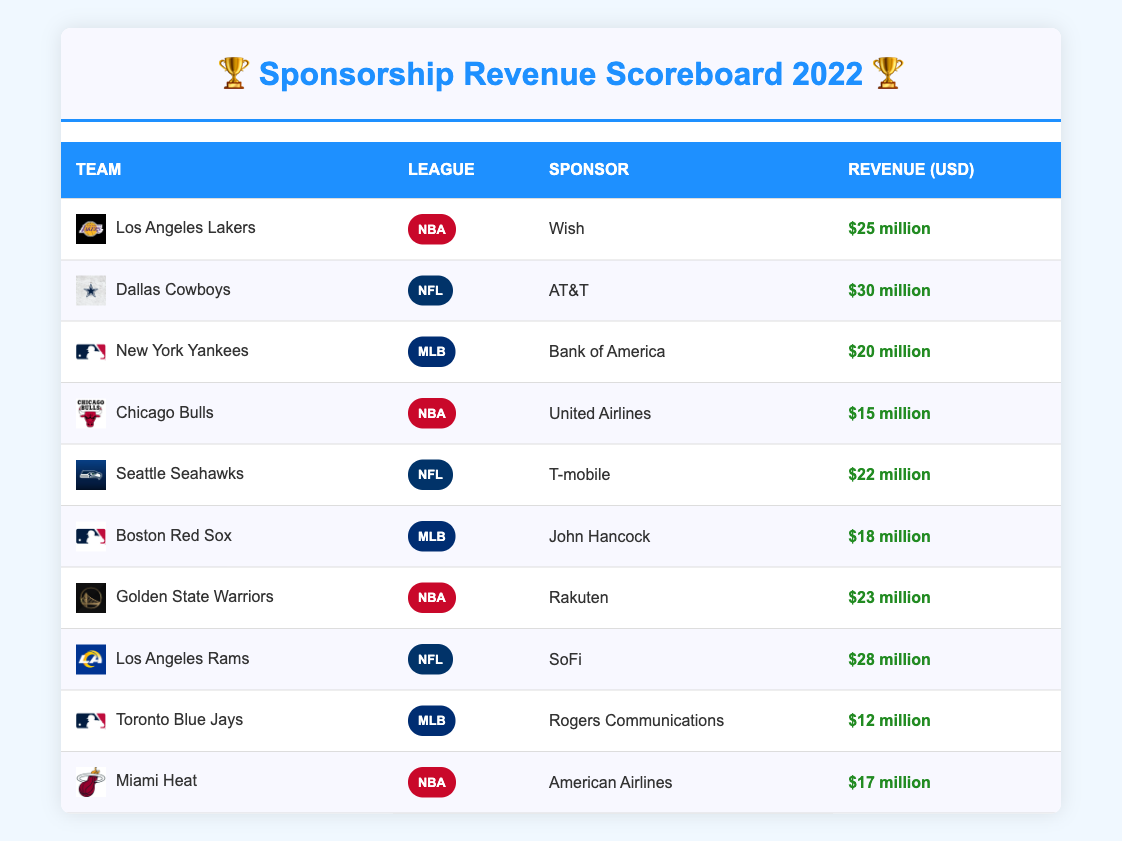What is the sponsorship revenue for the Dallas Cowboys? Looking at the table, the Dallas Cowboys are listed with a sponsorship revenue of $30 million.
Answer: $30 million Which NBA team has the highest sponsorship revenue? From the table, the Los Angeles Lakers have the highest sponsorship revenue among NBA teams at $25 million.
Answer: Los Angeles Lakers What is the total sponsorship revenue from all the teams? To find the total, we add up the revenues: 25 + 30 + 20 + 15 + 22 + 18 + 23 + 28 + 12 + 17 = 200. So, the total sponsorship revenue is $200 million.
Answer: $200 million Is the sponsorship revenue for the Miami Heat greater than that of the Chicago Bulls? The Miami Heat has a revenue of $17 million, while the Chicago Bulls have $15 million. Since 17 is greater than 15, the statement is true.
Answer: Yes What is the combined revenue of MLB teams in the table? To get the combined revenue for MLB teams, we sum their revenues: 20 (Yankees) + 18 (Red Sox) + 12 (Blue Jays) = 50. Therefore, the combined revenue for MLB teams is $50 million.
Answer: $50 million Which NFL team has a sponsorship revenue of less than $30 million? The Dallas Cowboys and Los Angeles Rams have revenues of $30 million and $28 million, respectively. The Los Angeles Rams, with $28 million, fits the criteria of being less than $30 million.
Answer: Los Angeles Rams How many teams have a sponsorship revenue of 20 million USD or more? From the table, the teams with revenues of 20 million or more are: Cowboys (30 million), Rams (28 million), Lakers (25 million), Warriors (23 million), Seahawks (22 million), Yankees (20 million). That totals to 6 teams.
Answer: 6 teams Are there any teams sponsored by major brands such as AT&T or Bank of America? Yes, the Dallas Cowboys are sponsored by AT&T, and the New York Yankees are sponsored by Bank of America. Therefore, this statement is true.
Answer: Yes What is the difference between the sponsorship revenue of the highest and lowest earning teams? The highest revenue is $30 million (Dallas Cowboys) and the lowest is $12 million (Toronto Blue Jays). Therefore, the difference is 30 - 12 = 18 million.
Answer: $18 million 